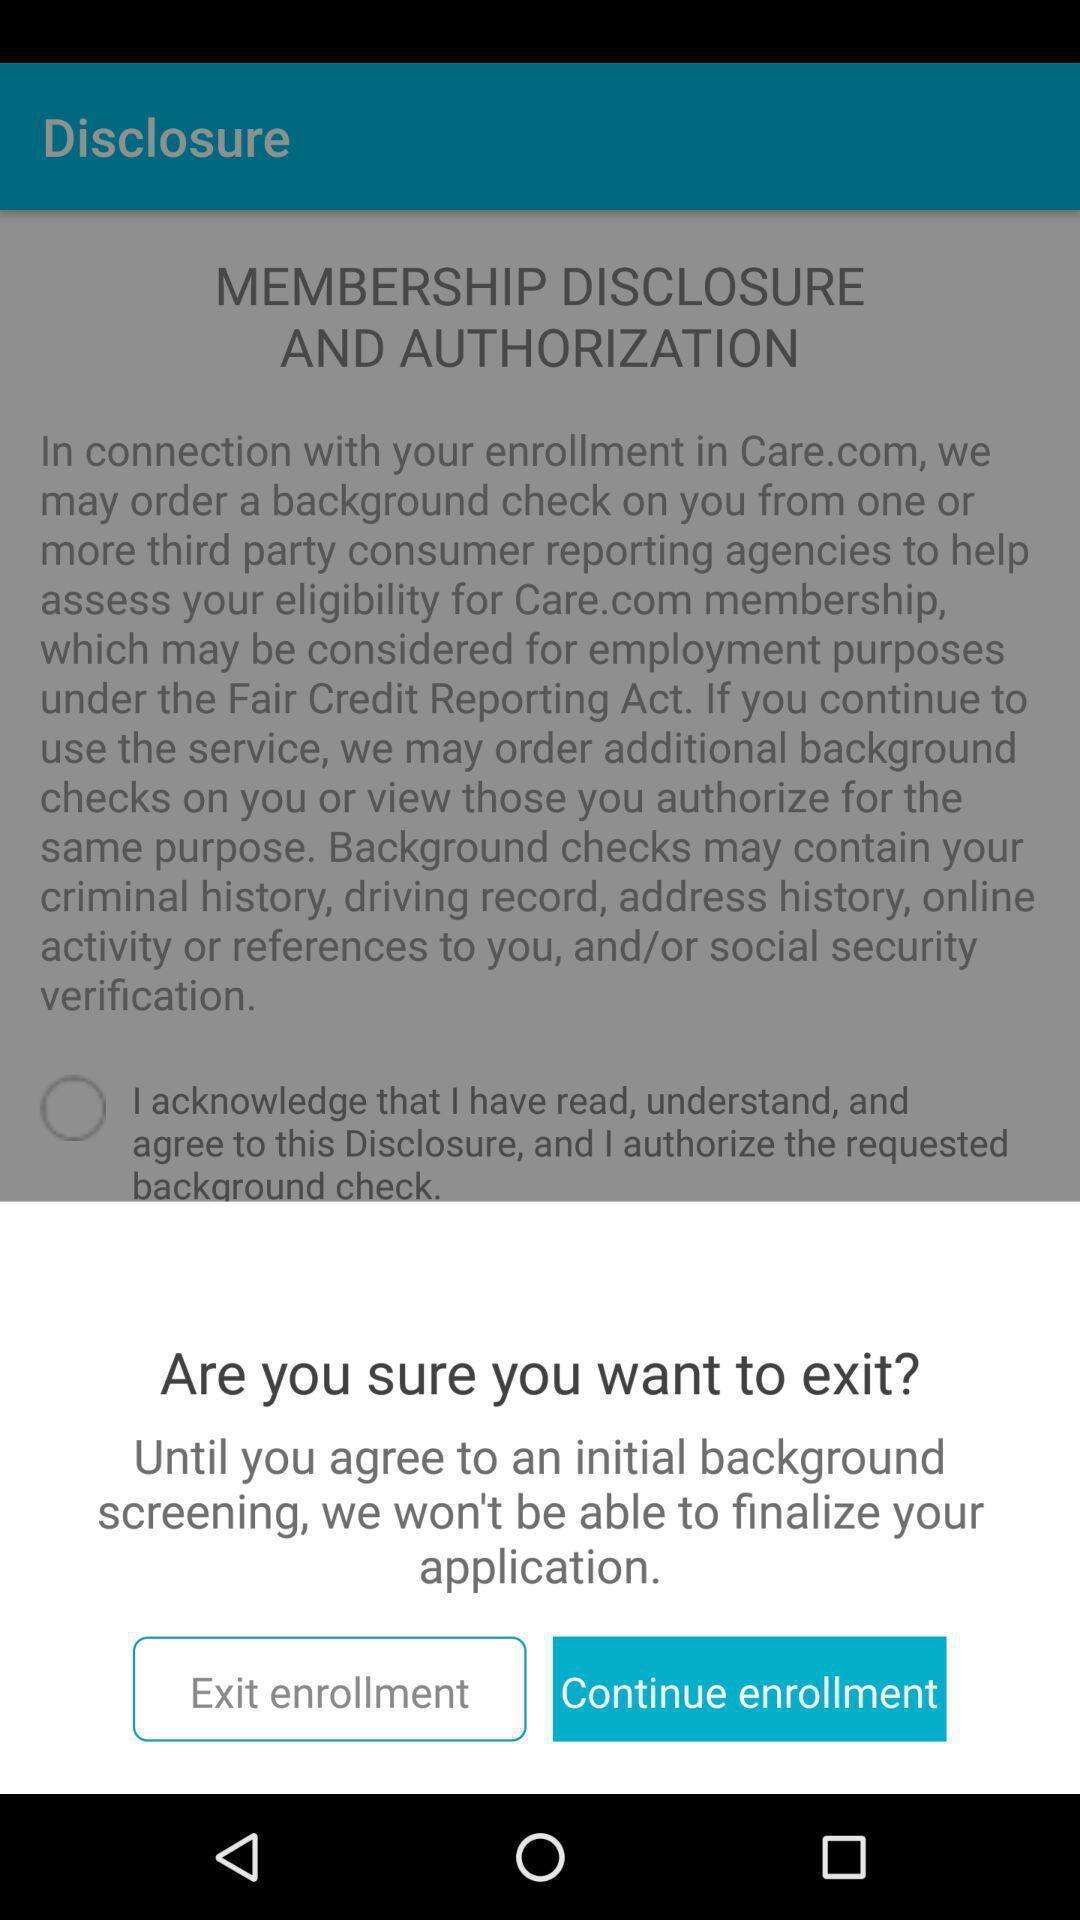Give me a narrative description of this picture. Pop-up showing for an exit or continue option. 